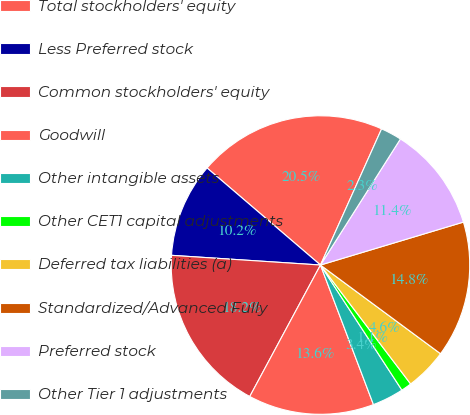Convert chart. <chart><loc_0><loc_0><loc_500><loc_500><pie_chart><fcel>Total stockholders' equity<fcel>Less Preferred stock<fcel>Common stockholders' equity<fcel>Goodwill<fcel>Other intangible assets<fcel>Other CET1 capital adjustments<fcel>Deferred tax liabilities (a)<fcel>Standardized/Advanced Fully<fcel>Preferred stock<fcel>Other Tier 1 adjustments<nl><fcel>20.45%<fcel>10.23%<fcel>18.18%<fcel>13.63%<fcel>3.41%<fcel>1.14%<fcel>4.55%<fcel>14.77%<fcel>11.36%<fcel>2.28%<nl></chart> 